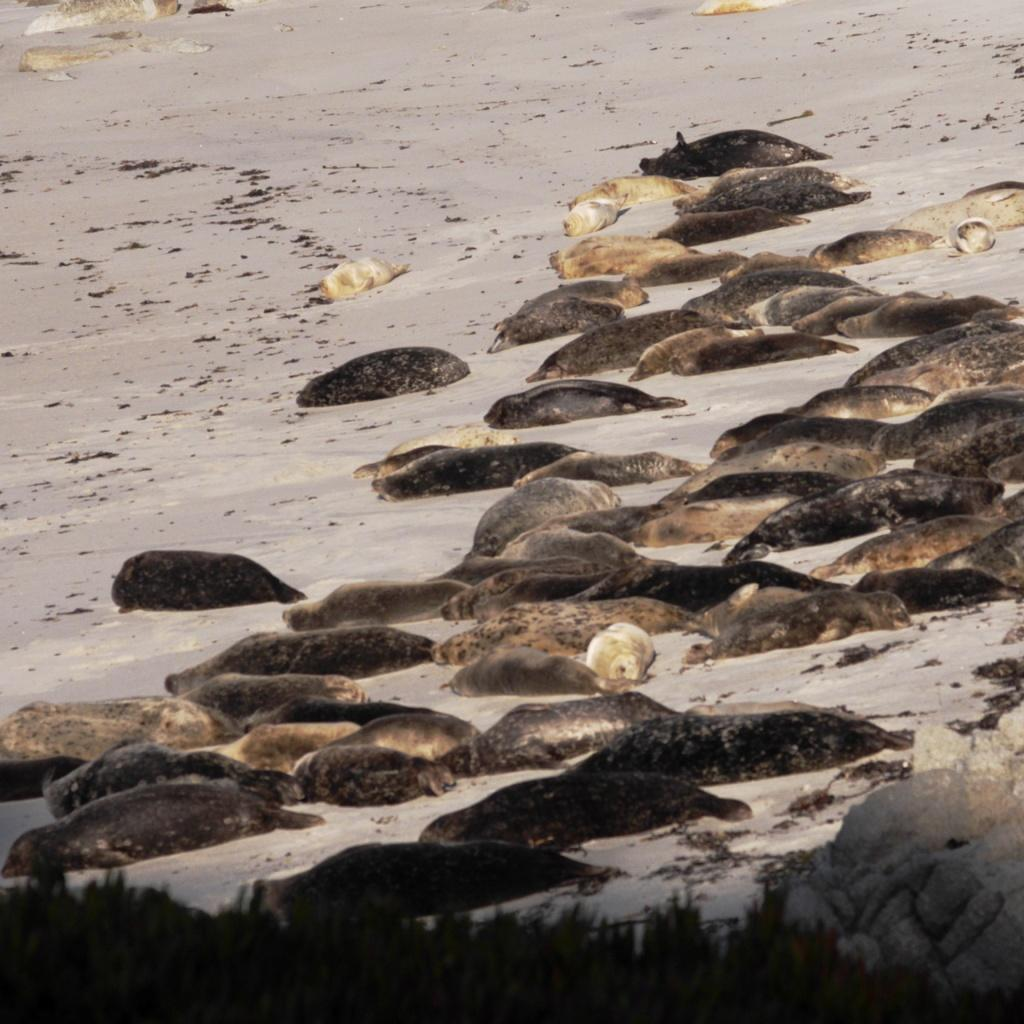What types of living organisms can be seen on the surface in the image? There are animals on the surface in the image. What can be found at the bottom of the image? There are plants at the bottom of the image. How does the glue hold the earth together in the image? There is no glue or earth present in the image; it features animals on the surface and plants at the bottom. 